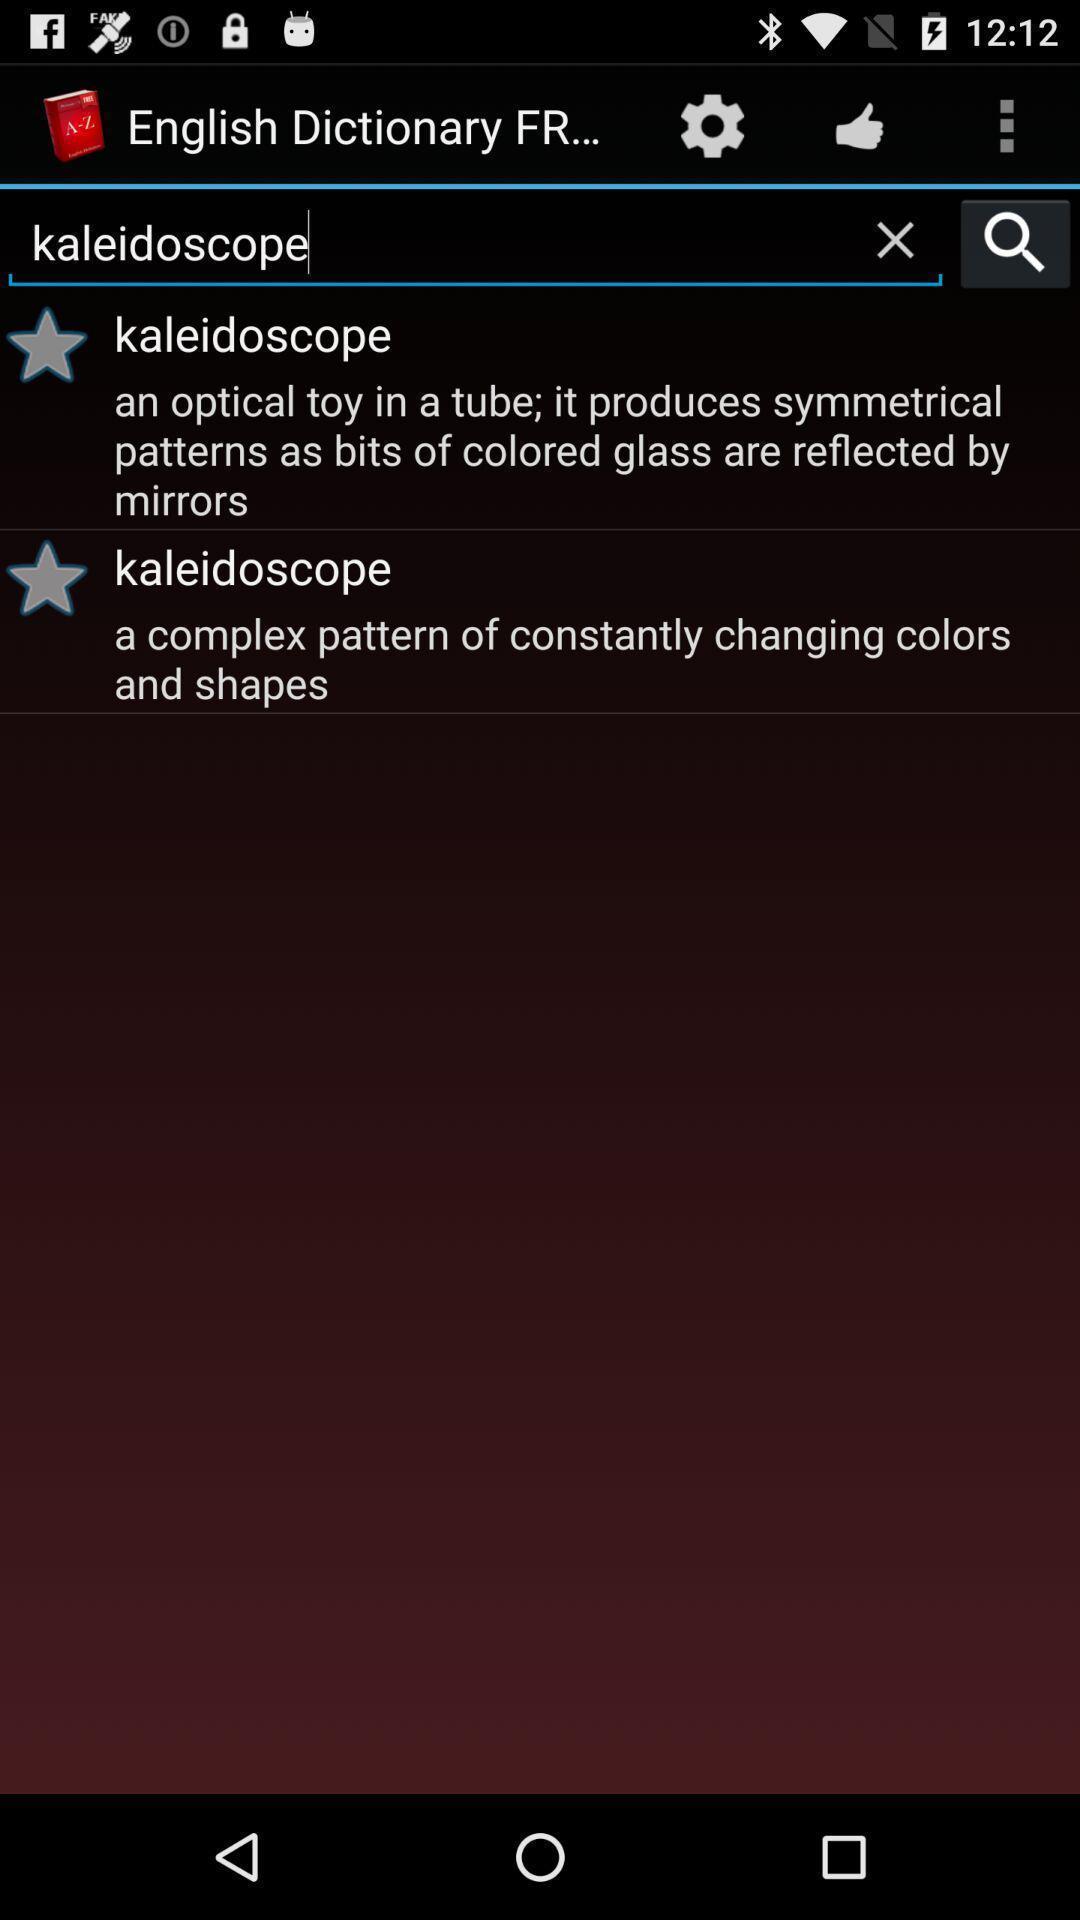Describe the visual elements of this screenshot. Screen showing page of an dictionary application with search bar. 